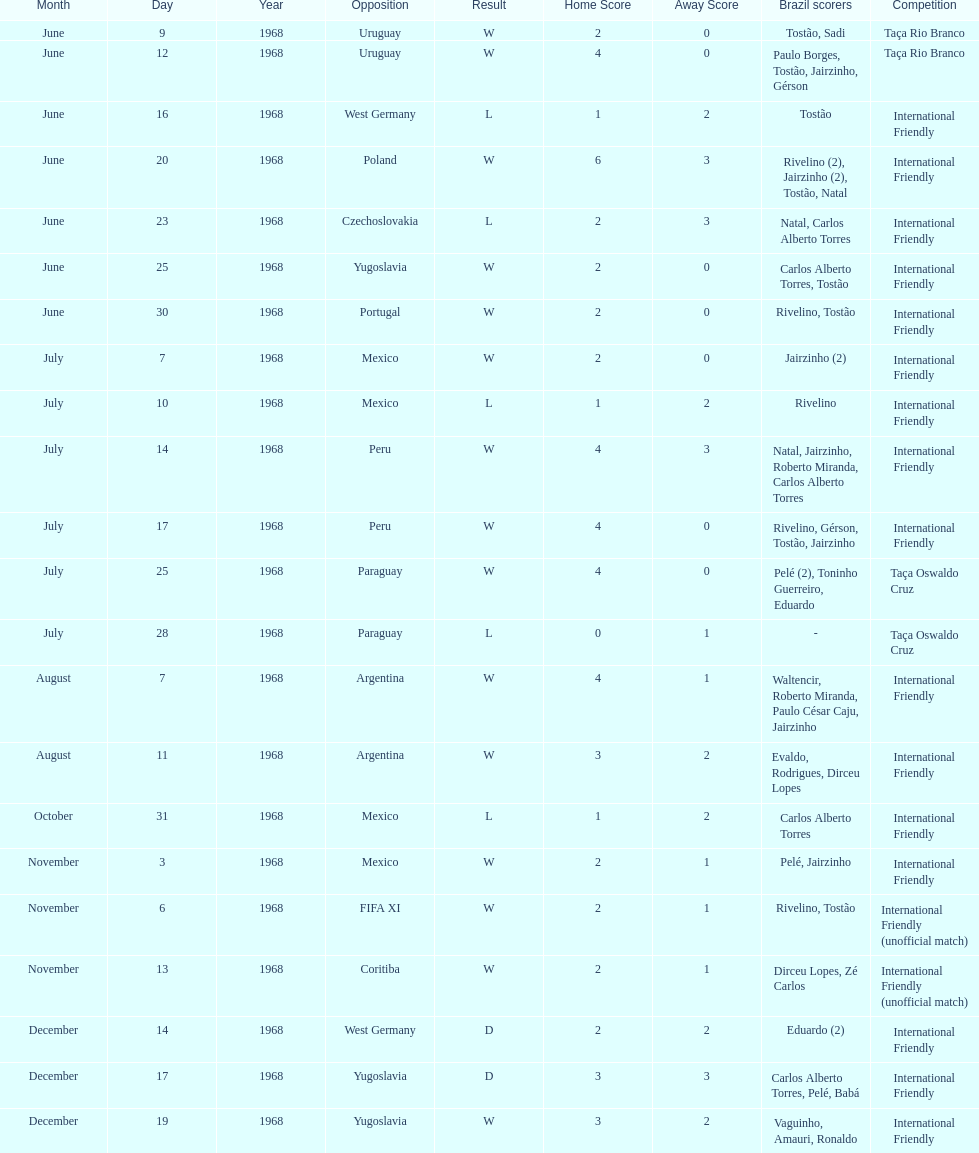What's the total number of ties? 2. 